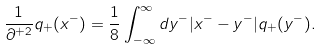Convert formula to latex. <formula><loc_0><loc_0><loc_500><loc_500>\frac { 1 } { \partial ^ { + 2 } } q _ { + } ( x ^ { - } ) = \frac { 1 } { 8 } \int ^ { \infty } _ { - \infty } d y ^ { - } | x ^ { - } - y ^ { - } | q _ { + } ( y ^ { - } ) .</formula> 